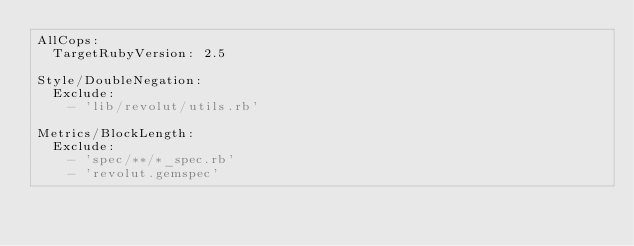<code> <loc_0><loc_0><loc_500><loc_500><_YAML_>AllCops:
  TargetRubyVersion: 2.5

Style/DoubleNegation:
  Exclude:
    - 'lib/revolut/utils.rb'

Metrics/BlockLength:
  Exclude:
    - 'spec/**/*_spec.rb'
    - 'revolut.gemspec'
</code> 